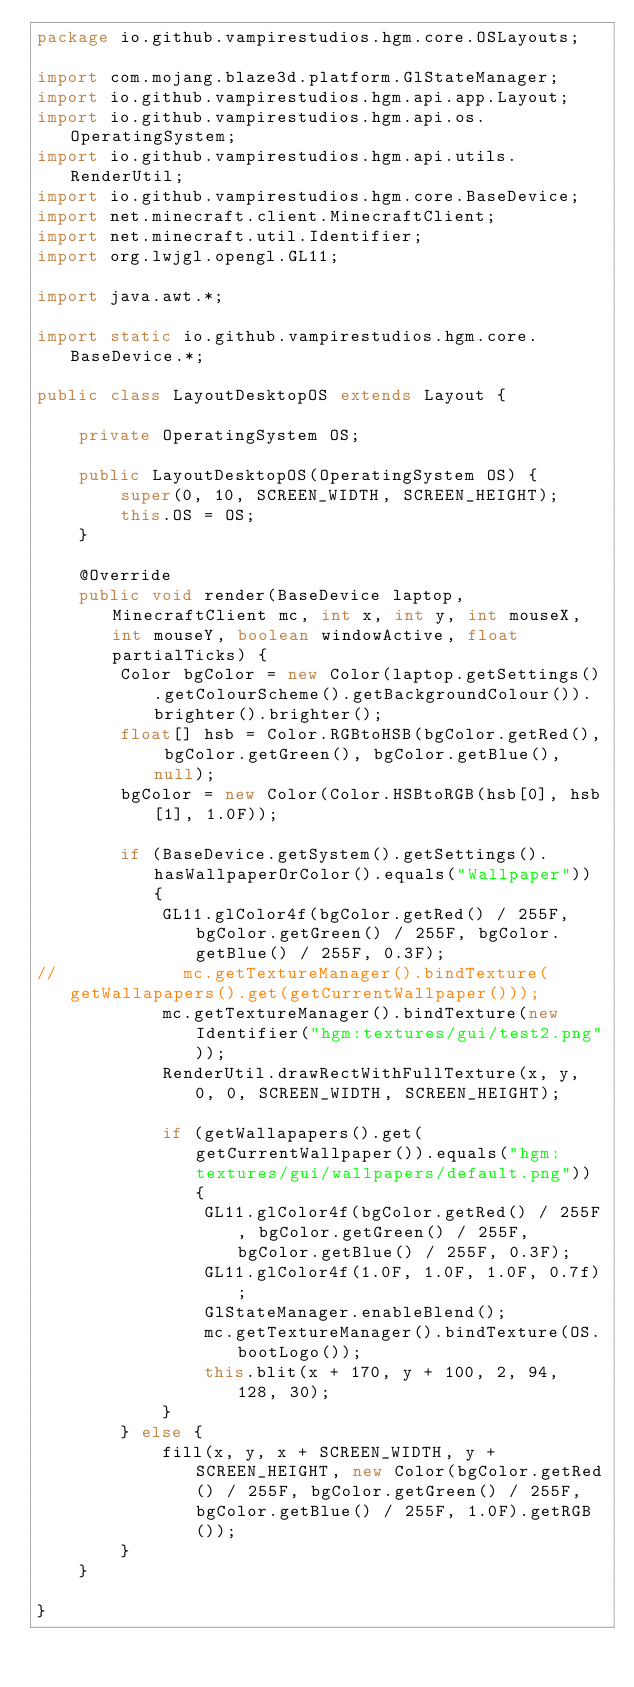Convert code to text. <code><loc_0><loc_0><loc_500><loc_500><_Java_>package io.github.vampirestudios.hgm.core.OSLayouts;

import com.mojang.blaze3d.platform.GlStateManager;
import io.github.vampirestudios.hgm.api.app.Layout;
import io.github.vampirestudios.hgm.api.os.OperatingSystem;
import io.github.vampirestudios.hgm.api.utils.RenderUtil;
import io.github.vampirestudios.hgm.core.BaseDevice;
import net.minecraft.client.MinecraftClient;
import net.minecraft.util.Identifier;
import org.lwjgl.opengl.GL11;

import java.awt.*;

import static io.github.vampirestudios.hgm.core.BaseDevice.*;

public class LayoutDesktopOS extends Layout {

    private OperatingSystem OS;

    public LayoutDesktopOS(OperatingSystem OS) {
        super(0, 10, SCREEN_WIDTH, SCREEN_HEIGHT);
        this.OS = OS;
    }

    @Override
    public void render(BaseDevice laptop, MinecraftClient mc, int x, int y, int mouseX, int mouseY, boolean windowActive, float partialTicks) {
        Color bgColor = new Color(laptop.getSettings().getColourScheme().getBackgroundColour()).brighter().brighter();
        float[] hsb = Color.RGBtoHSB(bgColor.getRed(), bgColor.getGreen(), bgColor.getBlue(), null);
        bgColor = new Color(Color.HSBtoRGB(hsb[0], hsb[1], 1.0F));

        if (BaseDevice.getSystem().getSettings().hasWallpaperOrColor().equals("Wallpaper")) {
            GL11.glColor4f(bgColor.getRed() / 255F, bgColor.getGreen() / 255F, bgColor.getBlue() / 255F, 0.3F);
//            mc.getTextureManager().bindTexture(getWallapapers().get(getCurrentWallpaper()));
            mc.getTextureManager().bindTexture(new Identifier("hgm:textures/gui/test2.png"));
            RenderUtil.drawRectWithFullTexture(x, y, 0, 0, SCREEN_WIDTH, SCREEN_HEIGHT);

            if (getWallapapers().get(getCurrentWallpaper()).equals("hgm:textures/gui/wallpapers/default.png")) {
                GL11.glColor4f(bgColor.getRed() / 255F, bgColor.getGreen() / 255F, bgColor.getBlue() / 255F, 0.3F);
                GL11.glColor4f(1.0F, 1.0F, 1.0F, 0.7f);
                GlStateManager.enableBlend();
                mc.getTextureManager().bindTexture(OS.bootLogo());
                this.blit(x + 170, y + 100, 2, 94, 128, 30);
            }
        } else {
            fill(x, y, x + SCREEN_WIDTH, y + SCREEN_HEIGHT, new Color(bgColor.getRed() / 255F, bgColor.getGreen() / 255F, bgColor.getBlue() / 255F, 1.0F).getRGB());
        }
    }

}
</code> 